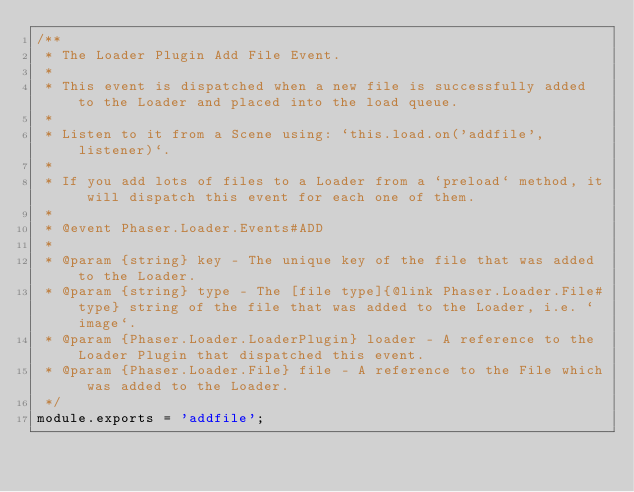Convert code to text. <code><loc_0><loc_0><loc_500><loc_500><_JavaScript_>/**
 * The Loader Plugin Add File Event.
 * 
 * This event is dispatched when a new file is successfully added to the Loader and placed into the load queue.
 * 
 * Listen to it from a Scene using: `this.load.on('addfile', listener)`.
 * 
 * If you add lots of files to a Loader from a `preload` method, it will dispatch this event for each one of them.
 *
 * @event Phaser.Loader.Events#ADD
 * 
 * @param {string} key - The unique key of the file that was added to the Loader.
 * @param {string} type - The [file type]{@link Phaser.Loader.File#type} string of the file that was added to the Loader, i.e. `image`.
 * @param {Phaser.Loader.LoaderPlugin} loader - A reference to the Loader Plugin that dispatched this event.
 * @param {Phaser.Loader.File} file - A reference to the File which was added to the Loader.
 */
module.exports = 'addfile';
</code> 